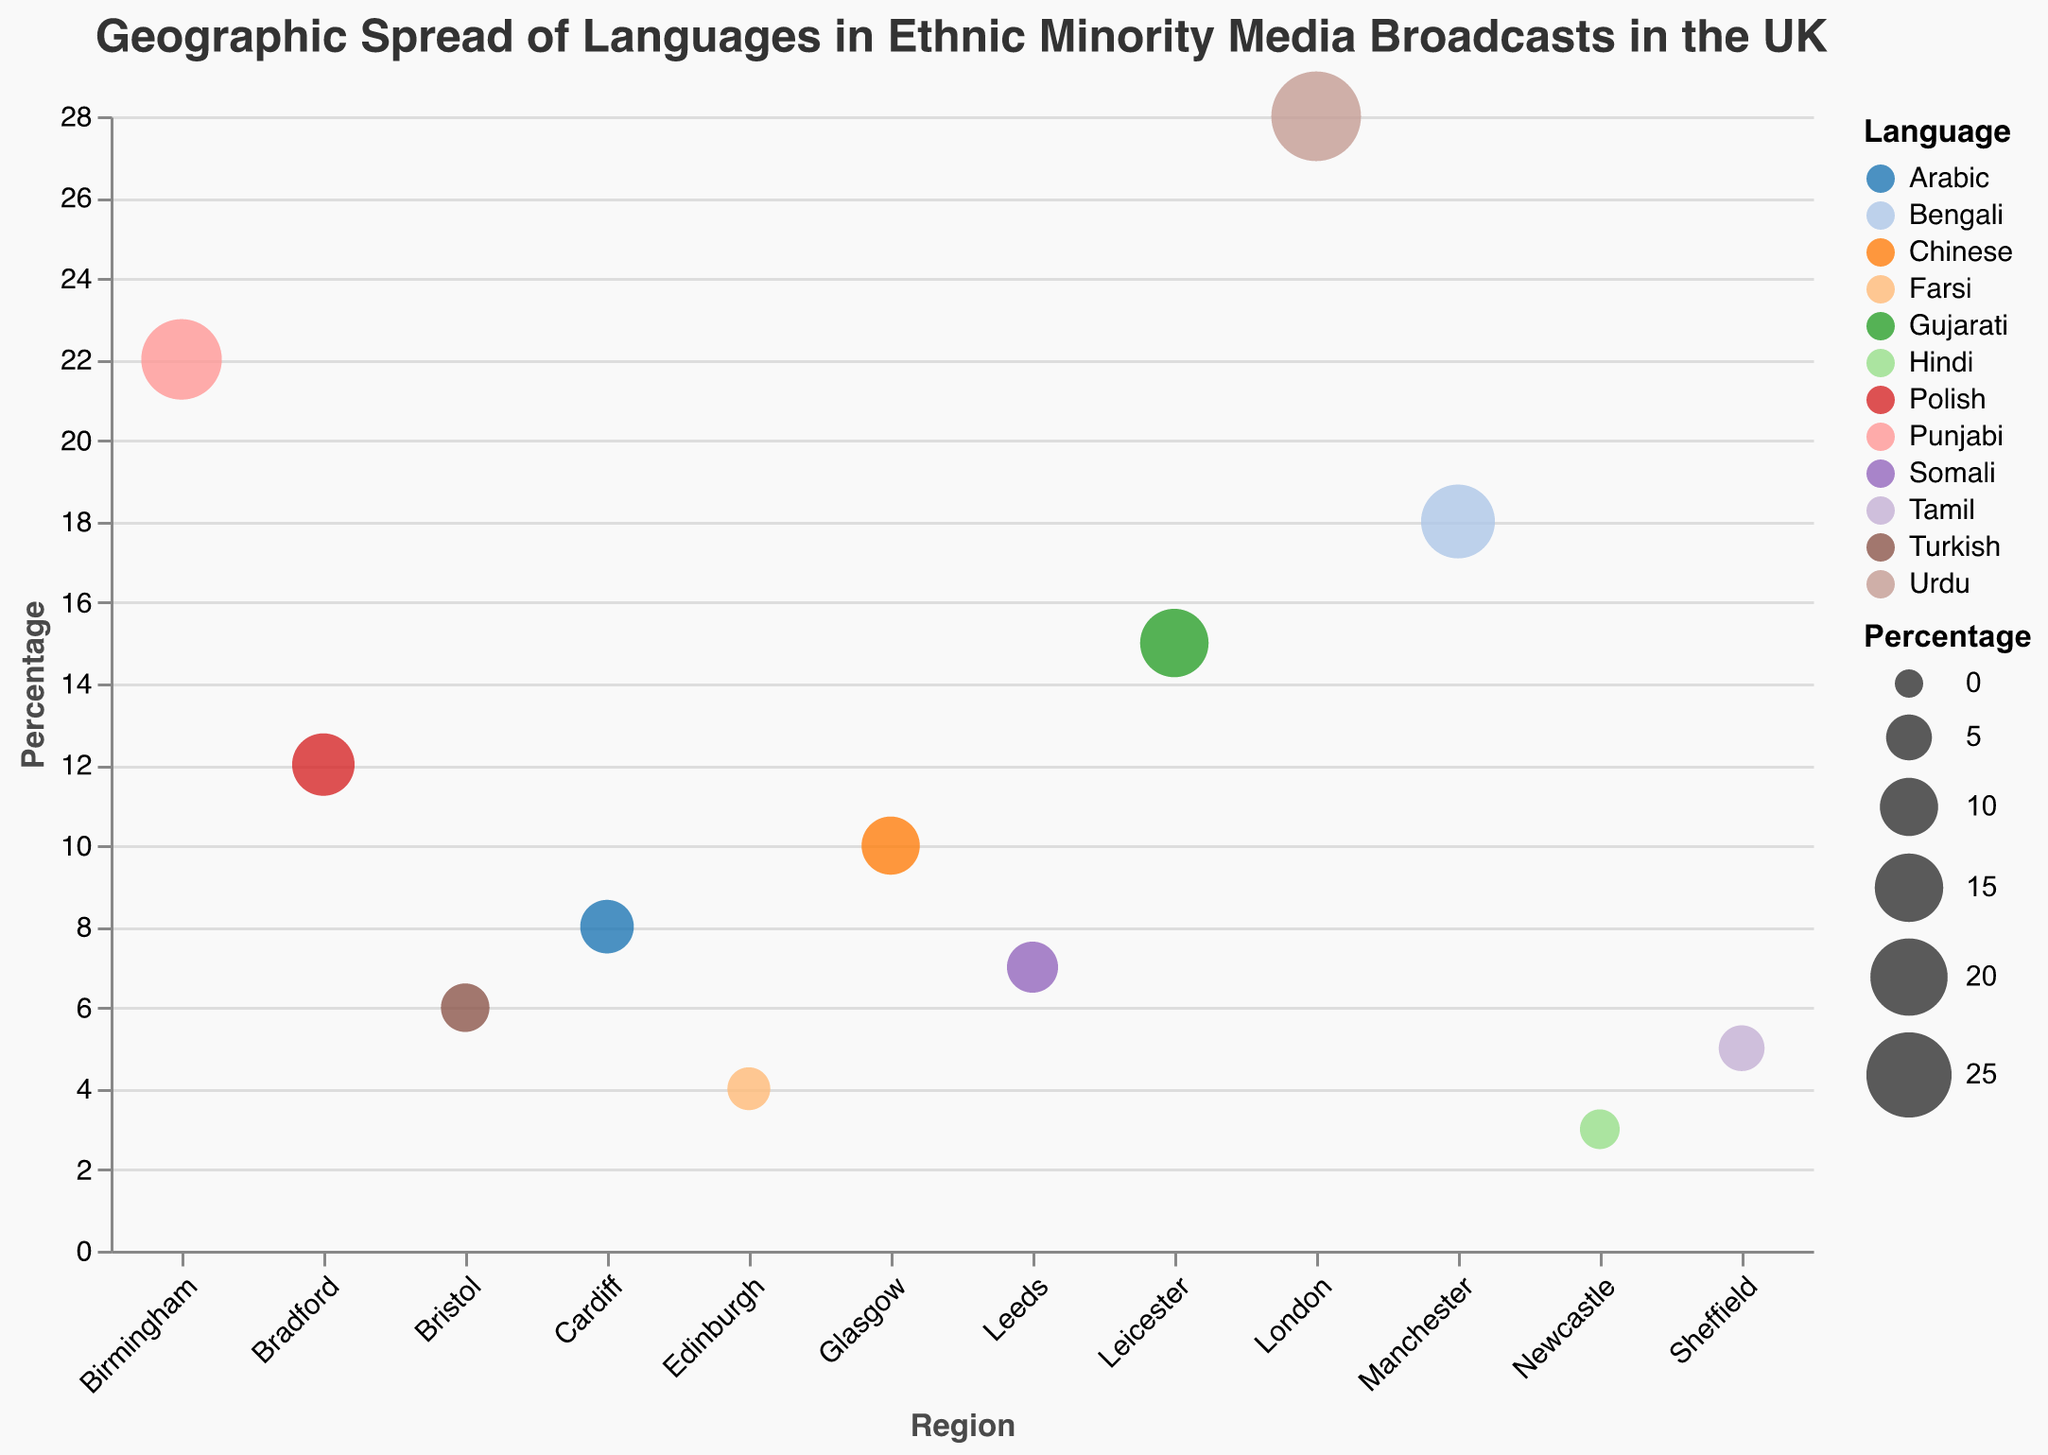How many regions are represented in the figure? Count the number of unique regions listed on the x-axis. There are 12 distinct regions: London, Birmingham, Manchester, Leicester, Bradford, Glasgow, Cardiff, Leeds, Bristol, Sheffield, Edinburgh, and Newcastle.
Answer: 12 Which region has the highest percentage of broadcasts in a single language and what is the language? Look at the y-axis and identify the highest data point, then check the corresponding region and language. London has the highest percentage at 28% in Urdu.
Answer: London, Urdu Which regions have languages with broadcast percentages greater than 20%? Check the y-axis values to identify all regions where the percentage is greater than 20. This includes London (28%), Birmingham (22%).
Answer: London, Birmingham What is the total percentage of broadcasts for the regions that have a percentage less than 10%? Sum the percentages of regions with broadcast percentages less than 10%: 10% (Glasgow) + 8% (Cardiff) + 7% (Leeds) + 6% (Bristol) + 5% (Sheffield) + 4% (Edinburgh) + 3% (Newcastle). 10 + 8 + 7 + 6 + 5 + 4 + 3 = 43.
Answer: 43% Which languages are represented in the figure, and how many are there? Identify all unique languages used in the broadcasts from the color legend. The languages are Urdu, Bengali, Punjabi, Gujarati, Polish, Chinese, Arabic, Somali, Turkish, Tamil, Farsi, and Hindi, totaling 12 languages.
Answer: 12 Which language is least represented and in which region? Identify the smallest circle size and corresponding region and language from the visual representation. The smallest percentage is 3% for Hindi in Newcastle.
Answer: Hindi, Newcastle What is the average percentage of broadcasts across all regions? Sum all percentages and divide by the number of regions: (28 + 22 + 18 + 15 + 12 + 10 + 8 + 7 + 6 + 5 + 4 + 3) / 12. Total sum is 138, so the average is 138 / 12 = 11.5.
Answer: 11.5% Which regions have a broadcast percentage exactly equal to 10%? Look for data points on the y-axis that match 10%, then refer to the corresponding region. Glasgow has a broadcast percentage of 10%.
Answer: Glasgow What is the percentage difference in broadcasts between Bradford (Polish) and Edinburgh (Farsi)? Subtract the percentage of Edinburgh from Bradford: 12% (Bradford, Polish) - 4% (Edinburgh, Farsi) = 8%.
Answer: 8% 